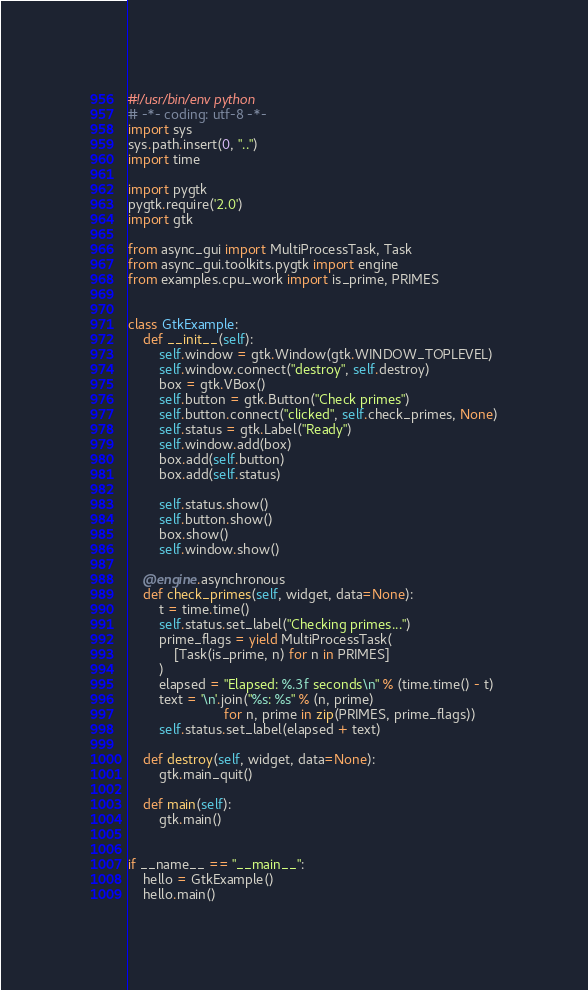Convert code to text. <code><loc_0><loc_0><loc_500><loc_500><_Python_>#!/usr/bin/env python
# -*- coding: utf-8 -*-
import sys
sys.path.insert(0, "..")
import time

import pygtk
pygtk.require('2.0')
import gtk

from async_gui import MultiProcessTask, Task
from async_gui.toolkits.pygtk import engine
from examples.cpu_work import is_prime, PRIMES


class GtkExample:
    def __init__(self):
        self.window = gtk.Window(gtk.WINDOW_TOPLEVEL)
        self.window.connect("destroy", self.destroy)
        box = gtk.VBox()
        self.button = gtk.Button("Check primes")
        self.button.connect("clicked", self.check_primes, None)
        self.status = gtk.Label("Ready")
        self.window.add(box)
        box.add(self.button)
        box.add(self.status)

        self.status.show()
        self.button.show()
        box.show()
        self.window.show()

    @engine.asynchronous
    def check_primes(self, widget, data=None):
        t = time.time()
        self.status.set_label("Checking primes...")
        prime_flags = yield MultiProcessTask(
            [Task(is_prime, n) for n in PRIMES]
        )
        elapsed = "Elapsed: %.3f seconds\n" % (time.time() - t)
        text = '\n'.join("%s: %s" % (n, prime)
                         for n, prime in zip(PRIMES, prime_flags))
        self.status.set_label(elapsed + text)

    def destroy(self, widget, data=None):
        gtk.main_quit()

    def main(self):
        gtk.main()


if __name__ == "__main__":
    hello = GtkExample()
    hello.main()
</code> 